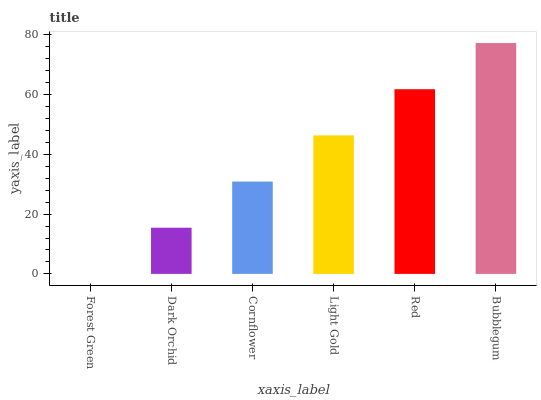Is Forest Green the minimum?
Answer yes or no. Yes. Is Bubblegum the maximum?
Answer yes or no. Yes. Is Dark Orchid the minimum?
Answer yes or no. No. Is Dark Orchid the maximum?
Answer yes or no. No. Is Dark Orchid greater than Forest Green?
Answer yes or no. Yes. Is Forest Green less than Dark Orchid?
Answer yes or no. Yes. Is Forest Green greater than Dark Orchid?
Answer yes or no. No. Is Dark Orchid less than Forest Green?
Answer yes or no. No. Is Light Gold the high median?
Answer yes or no. Yes. Is Cornflower the low median?
Answer yes or no. Yes. Is Bubblegum the high median?
Answer yes or no. No. Is Forest Green the low median?
Answer yes or no. No. 